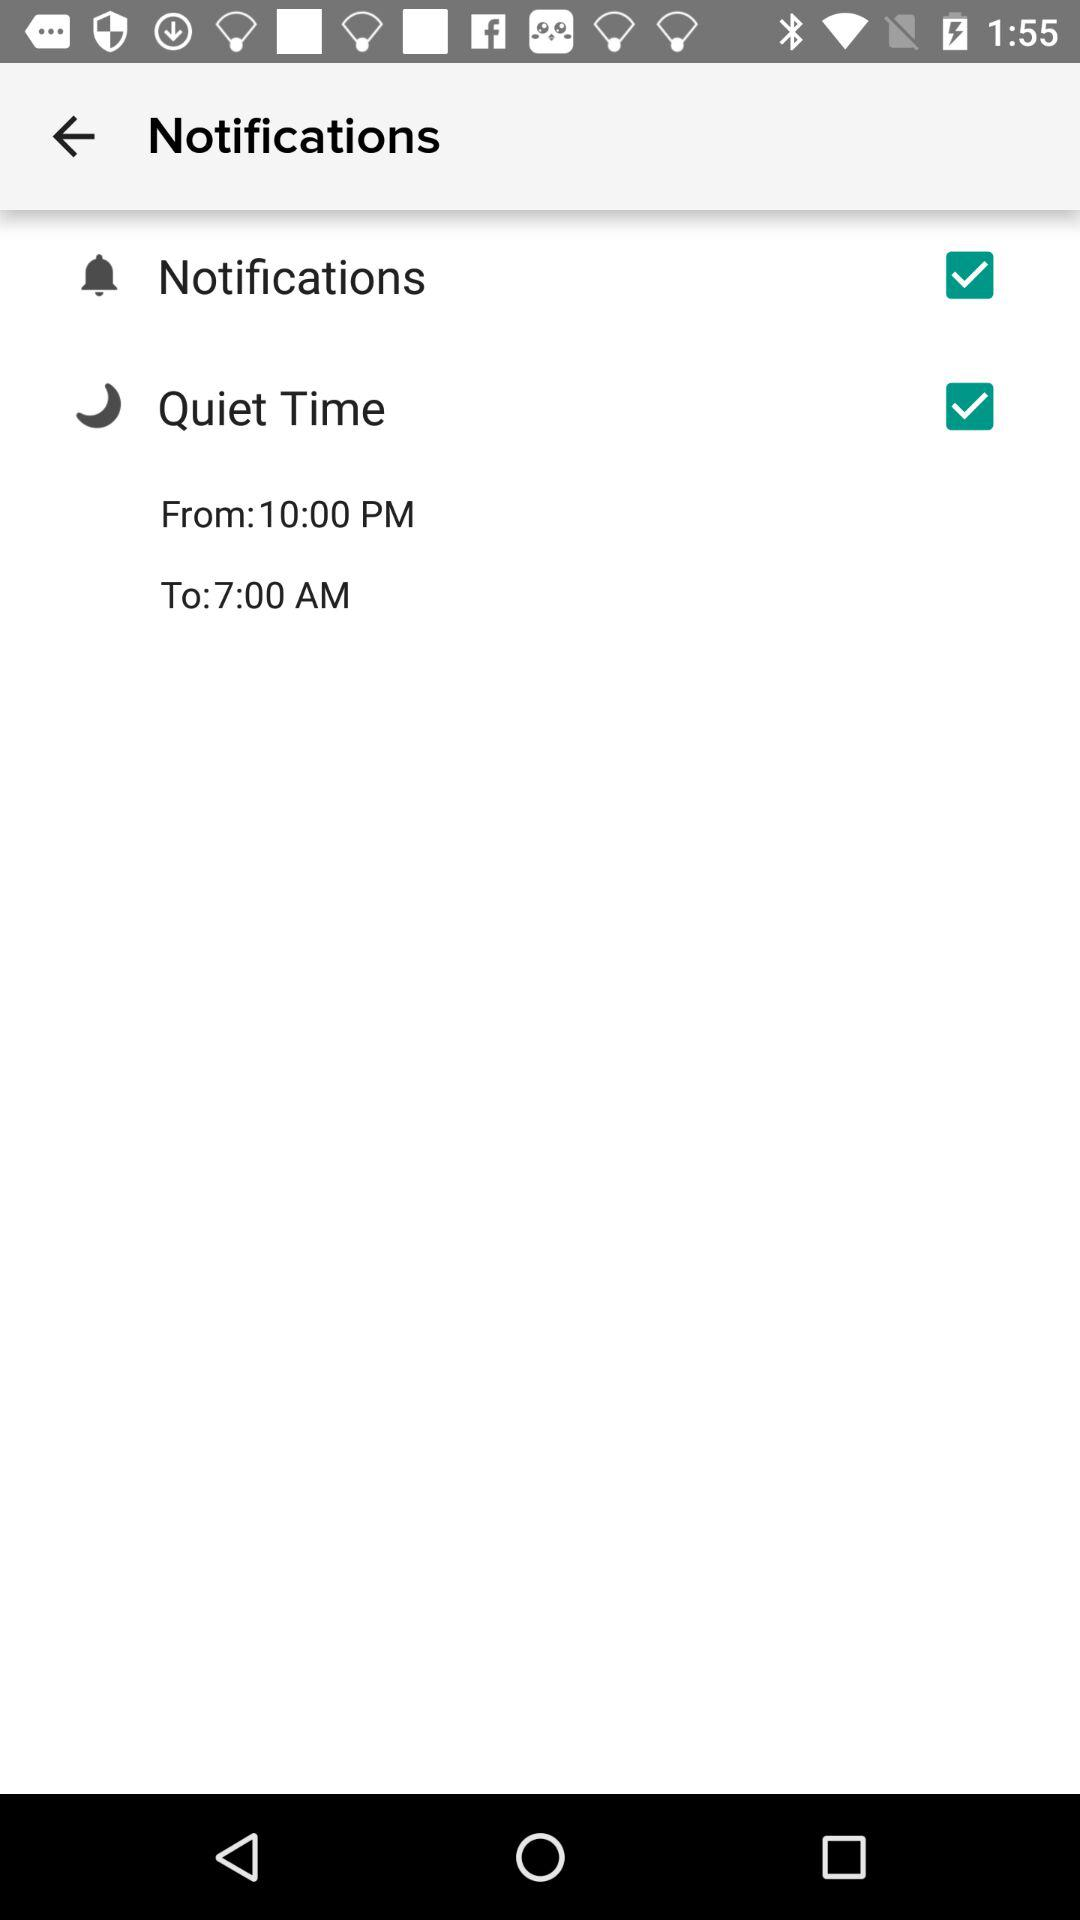What is the status of the "Notifications"? The status of the "Notifications" is "on". 